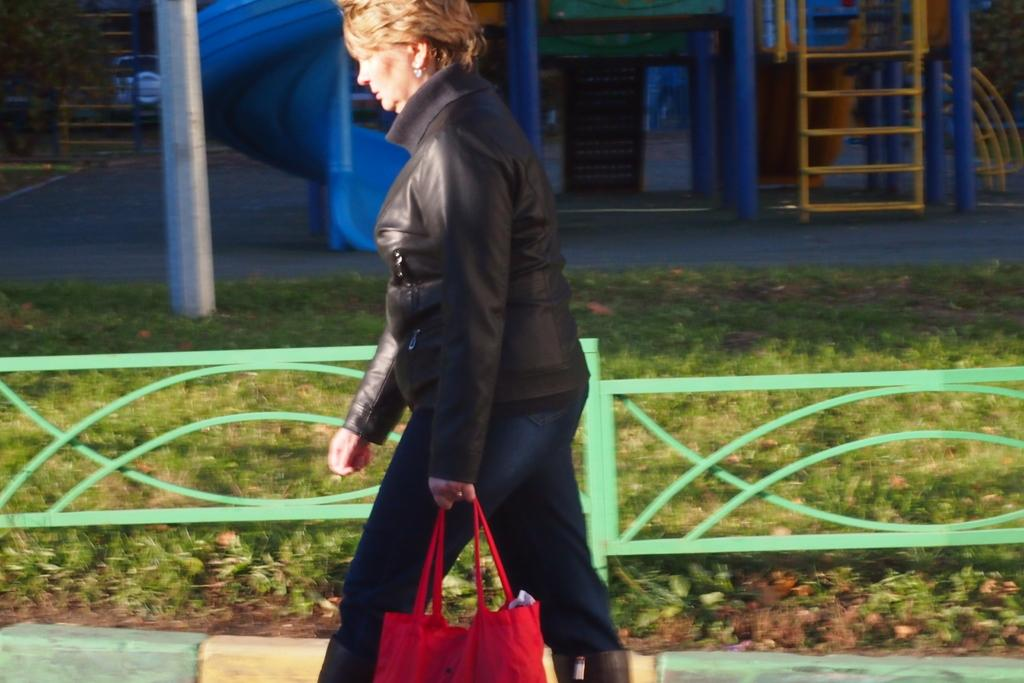What type of vegetation is present in the image? There is grass in the image. What type of structure can be seen in the image? There is a house in the image. What is the woman in the image wearing? The woman is wearing a black dress in the image. What accessory is the woman holding in the image? The woman is holding a red handbag in the image. What type of crack can be seen in the woman's dress in the image? There is no crack visible in the woman's dress in the image. What type of liquid is present in the image? There is no liquid present in the image. 